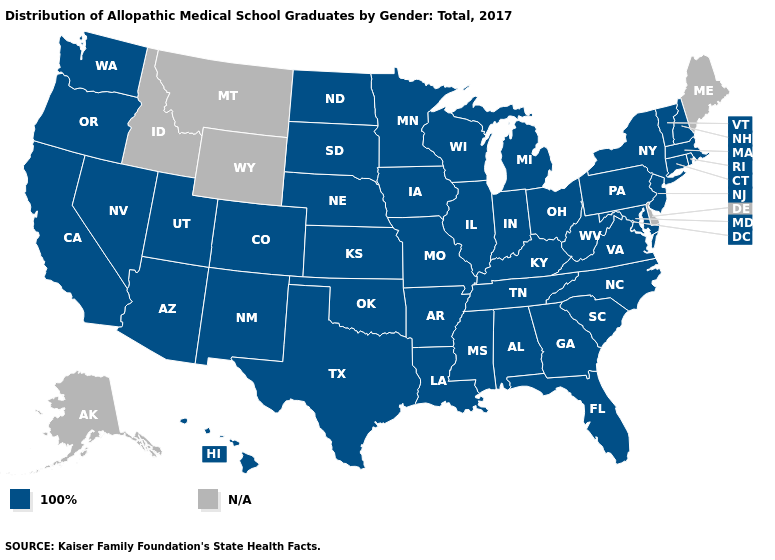Name the states that have a value in the range 100%?
Keep it brief. Alabama, Arizona, Arkansas, California, Colorado, Connecticut, Florida, Georgia, Hawaii, Illinois, Indiana, Iowa, Kansas, Kentucky, Louisiana, Maryland, Massachusetts, Michigan, Minnesota, Mississippi, Missouri, Nebraska, Nevada, New Hampshire, New Jersey, New Mexico, New York, North Carolina, North Dakota, Ohio, Oklahoma, Oregon, Pennsylvania, Rhode Island, South Carolina, South Dakota, Tennessee, Texas, Utah, Vermont, Virginia, Washington, West Virginia, Wisconsin. Does the map have missing data?
Keep it brief. Yes. How many symbols are there in the legend?
Short answer required. 2. What is the highest value in the Northeast ?
Give a very brief answer. 100%. What is the value of Arizona?
Quick response, please. 100%. What is the highest value in the USA?
Quick response, please. 100%. Name the states that have a value in the range N/A?
Answer briefly. Alaska, Delaware, Idaho, Maine, Montana, Wyoming. Name the states that have a value in the range 100%?
Give a very brief answer. Alabama, Arizona, Arkansas, California, Colorado, Connecticut, Florida, Georgia, Hawaii, Illinois, Indiana, Iowa, Kansas, Kentucky, Louisiana, Maryland, Massachusetts, Michigan, Minnesota, Mississippi, Missouri, Nebraska, Nevada, New Hampshire, New Jersey, New Mexico, New York, North Carolina, North Dakota, Ohio, Oklahoma, Oregon, Pennsylvania, Rhode Island, South Carolina, South Dakota, Tennessee, Texas, Utah, Vermont, Virginia, Washington, West Virginia, Wisconsin. Does the map have missing data?
Quick response, please. Yes. What is the value of Iowa?
Concise answer only. 100%. 